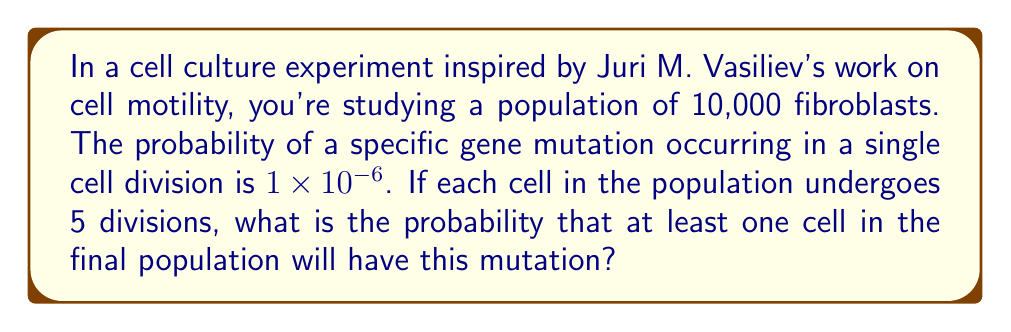Could you help me with this problem? Let's approach this step-by-step:

1) First, we need to calculate the probability of a cell not having the mutation after 5 divisions:
   $P(\text{no mutation in 5 divisions}) = (1 - 10^{-6})^5 = 0.999995$

2) Now, we can calculate the probability of a cell having at least one mutation:
   $P(\text{at least one mutation}) = 1 - P(\text{no mutation}) = 1 - 0.999995 = 5 \times 10^{-6}$

3) In the final population, we have 10,000 cells that have each undergone 5 divisions. We want to find the probability that at least one of these cells has the mutation. It's easier to calculate the probability that none of them have the mutation and then subtract from 1:

   $P(\text{no cells with mutation}) = (0.999995)^{10000} = 0.9512$

4) Therefore, the probability that at least one cell has the mutation is:
   $P(\text{at least one cell with mutation}) = 1 - P(\text{no cells with mutation})$
   $= 1 - 0.9512 = 0.0488$

5) This can be expressed as a percentage:
   $0.0488 \times 100\% = 4.88\%$
Answer: 4.88% 